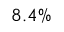Convert formula to latex. <formula><loc_0><loc_0><loc_500><loc_500>8 . 4 \%</formula> 